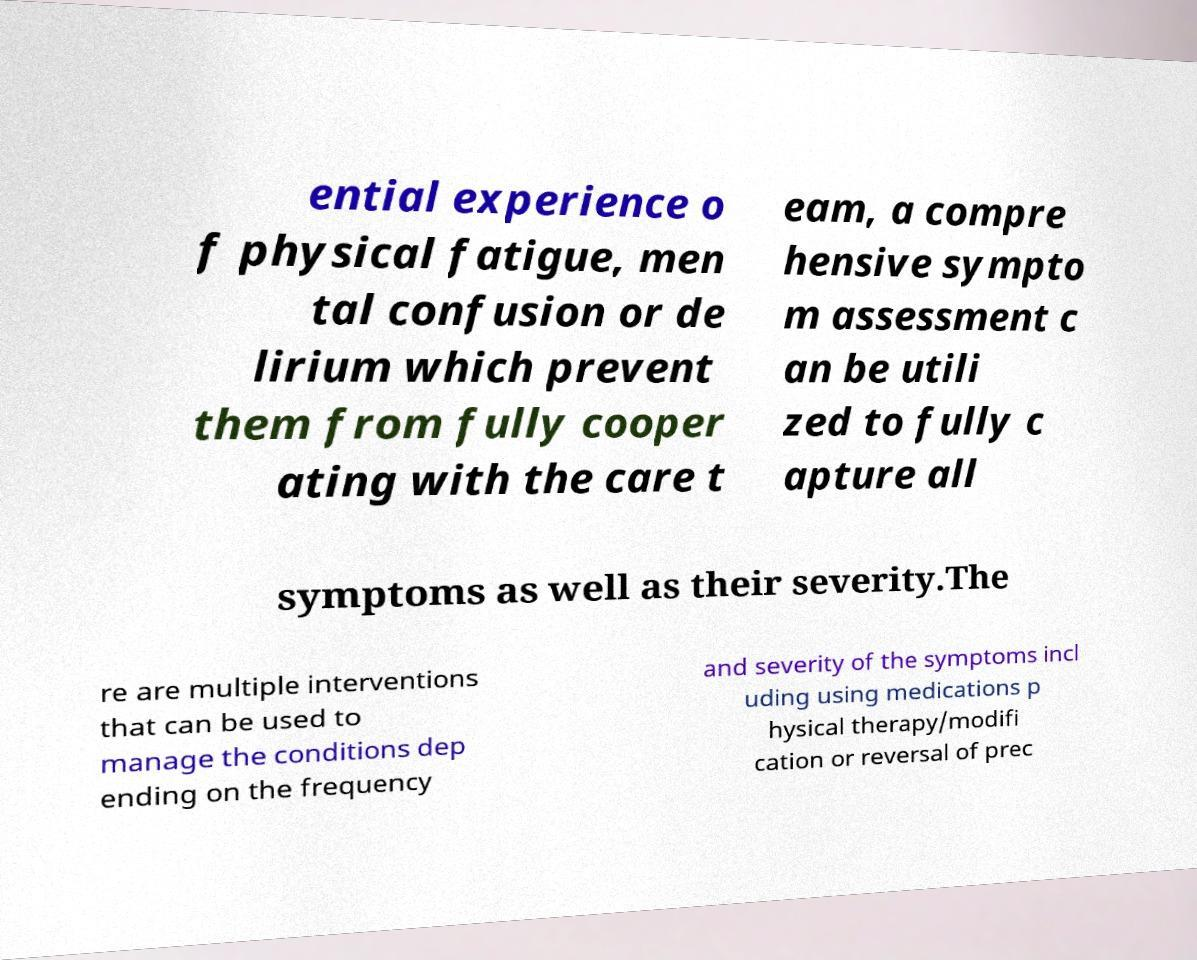Can you read and provide the text displayed in the image?This photo seems to have some interesting text. Can you extract and type it out for me? ential experience o f physical fatigue, men tal confusion or de lirium which prevent them from fully cooper ating with the care t eam, a compre hensive sympto m assessment c an be utili zed to fully c apture all symptoms as well as their severity.The re are multiple interventions that can be used to manage the conditions dep ending on the frequency and severity of the symptoms incl uding using medications p hysical therapy/modifi cation or reversal of prec 